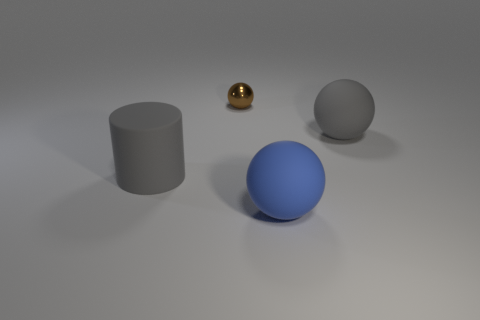Add 2 tiny brown balls. How many objects exist? 6 Subtract all spheres. How many objects are left? 1 Subtract all big gray metal blocks. Subtract all big gray balls. How many objects are left? 3 Add 1 large blue spheres. How many large blue spheres are left? 2 Add 4 big shiny things. How many big shiny things exist? 4 Subtract 0 brown cubes. How many objects are left? 4 